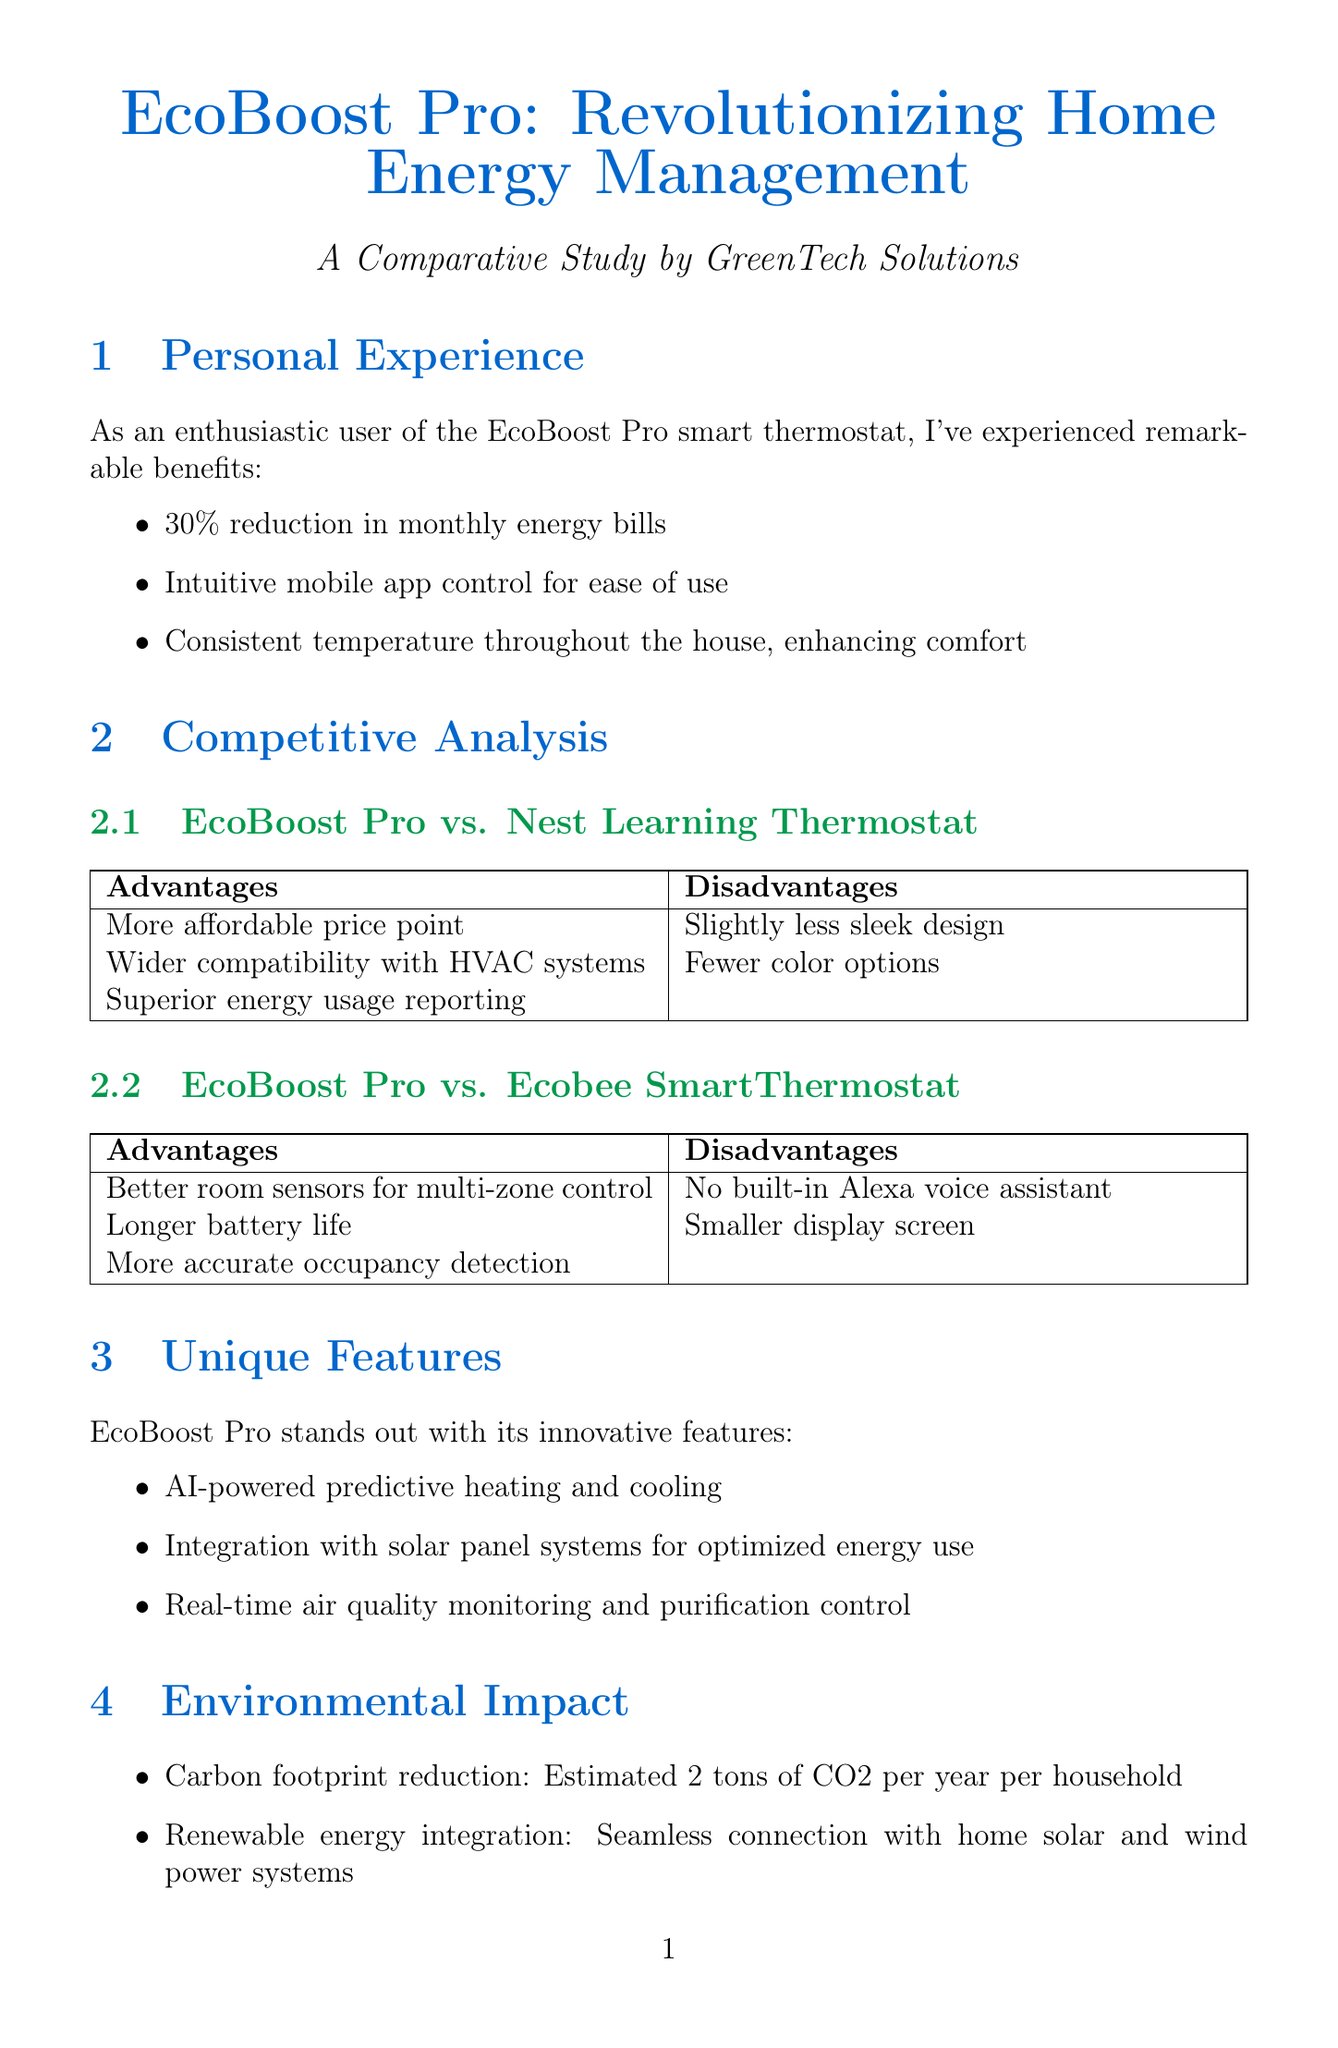What is the product name? The product name is mentioned at the beginning of the document under the title section.
Answer: EcoBoost Pro What percentage reduction in energy bills does EcoBoost Pro provide? The document states that users experience a specific percentage reduction in their monthly energy bills under personal experience.
Answer: 30% Who is the company behind EcoBoost Pro? The company name is listed in the introductory section of the document.
Answer: GreenTech Solutions What unique feature allows for monitoring air quality? The document highlights unique features of the EcoBoost Pro, one of which pertains to air quality.
Answer: Real-time air quality monitoring and purification control How much CO2 does EcoBoost Pro help reduce per year per household? The document includes an estimate of the carbon footprint reduction in the environmental impact section.
Answer: 2 tons What award did EcoBoost Pro win in 2023? The document lists industry recognition awards in its respective section, specifying the year and the award.
Answer: Green Product of the Year Which competitor offers better room sensors for multi-zone control? The competitive analysis compares features of EcoBoost Pro against its competitors, pinpointing their advantages.
Answer: Ecobee SmartThermostat What future development involves smart home integration? The document mentions future developments that the company is focusing on, including integration with smart home ecosystems.
Answer: Integration with smart home ecosystems like Apple HomeKit and Google Home What has Sarah Johnson quoted about EcoBoost Pro? The document includes customer testimonials, presenting opinions from users of the product.
Answer: Revolutionized how I manage my home's energy consumption 